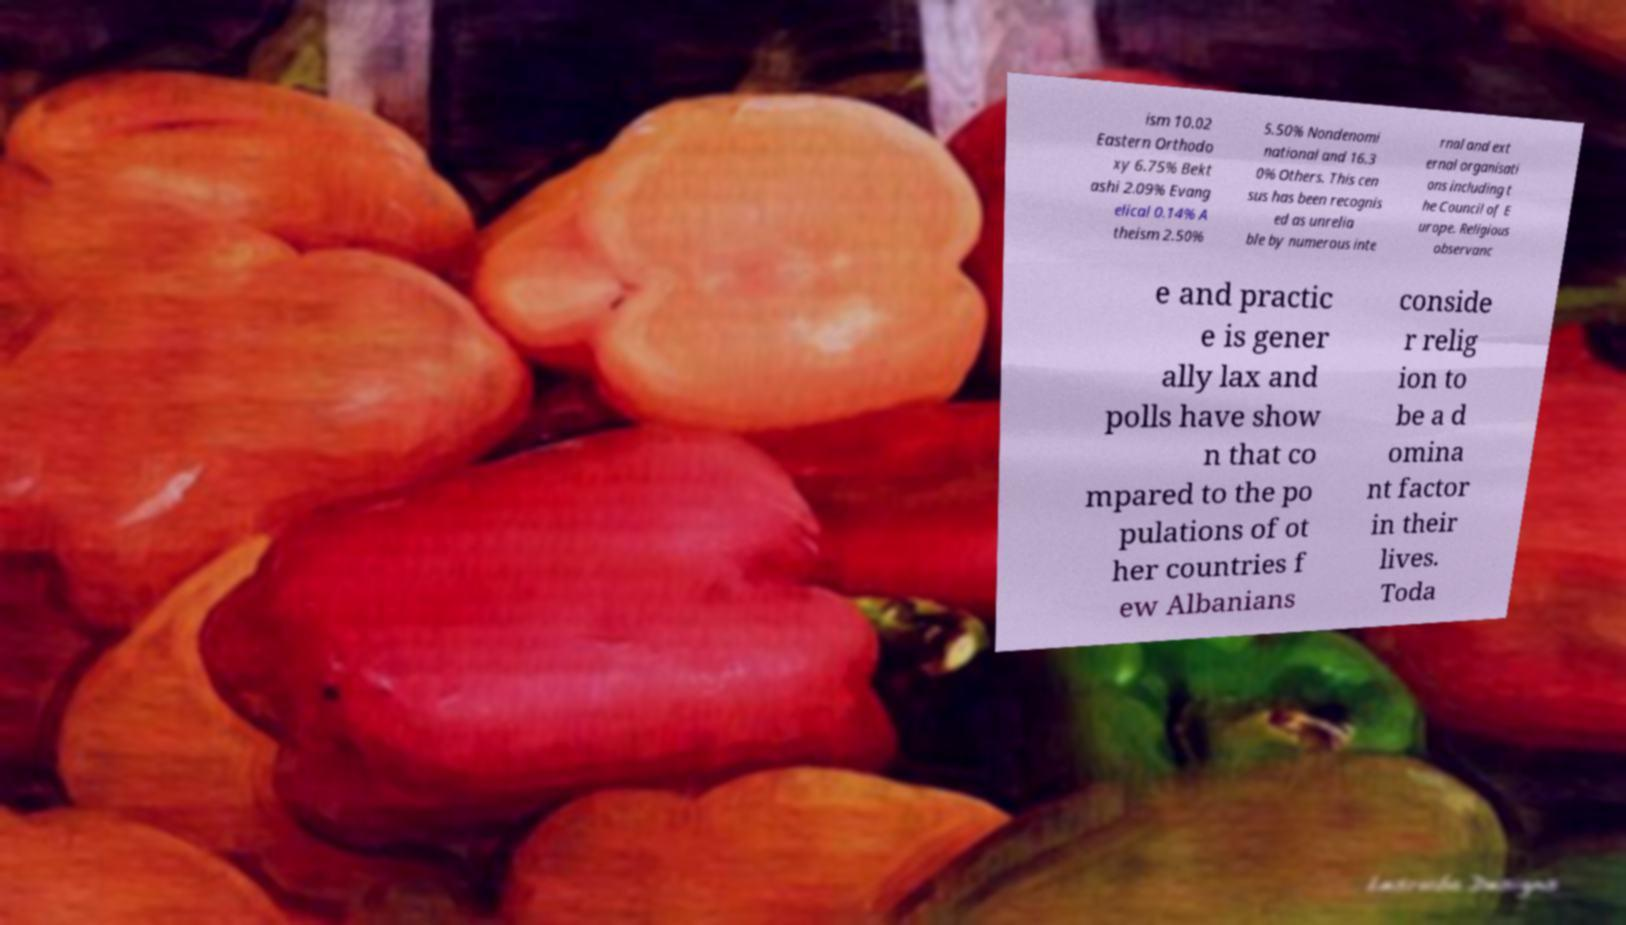Please read and relay the text visible in this image. What does it say? ism 10.02 Eastern Orthodo xy 6.75% Bekt ashi 2.09% Evang elical 0.14% A theism 2.50% 5.50% Nondenomi national and 16.3 0% Others. This cen sus has been recognis ed as unrelia ble by numerous inte rnal and ext ernal organisati ons including t he Council of E urope. Religious observanc e and practic e is gener ally lax and polls have show n that co mpared to the po pulations of ot her countries f ew Albanians conside r relig ion to be a d omina nt factor in their lives. Toda 